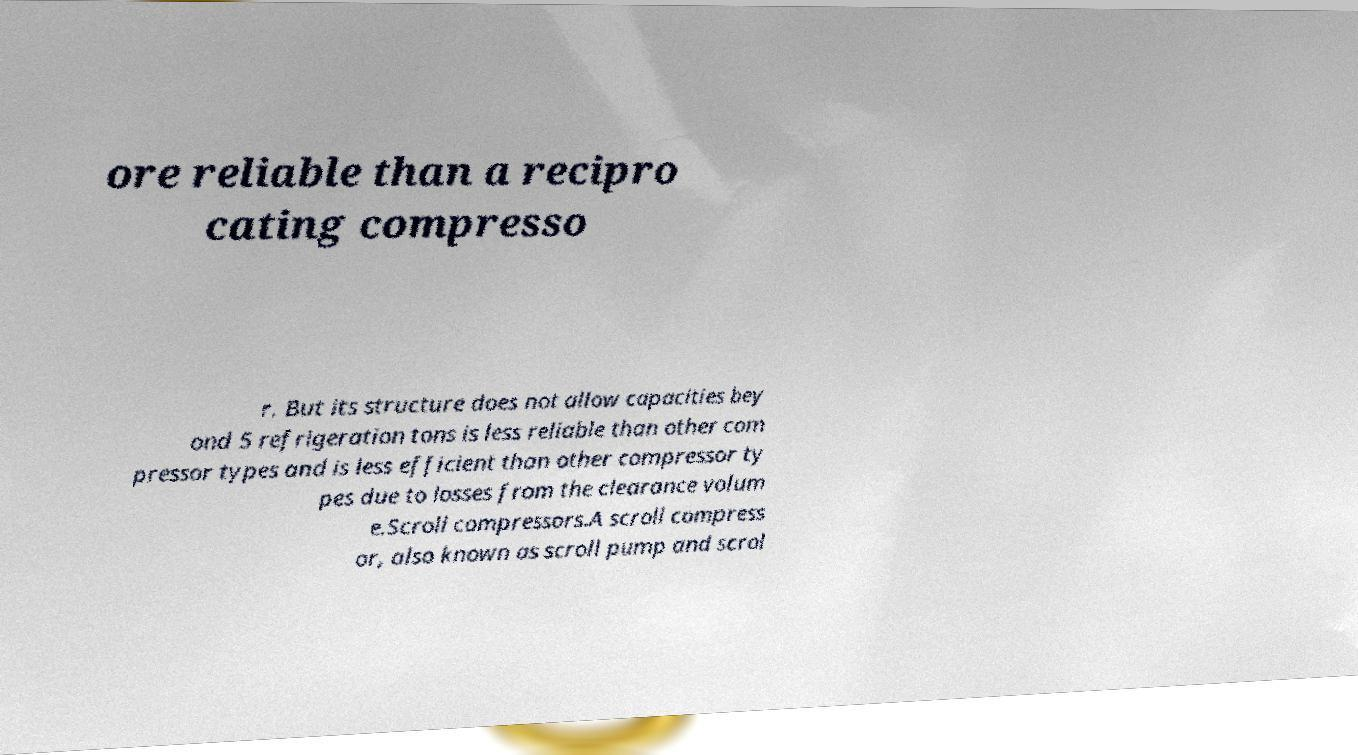There's text embedded in this image that I need extracted. Can you transcribe it verbatim? ore reliable than a recipro cating compresso r. But its structure does not allow capacities bey ond 5 refrigeration tons is less reliable than other com pressor types and is less efficient than other compressor ty pes due to losses from the clearance volum e.Scroll compressors.A scroll compress or, also known as scroll pump and scrol 